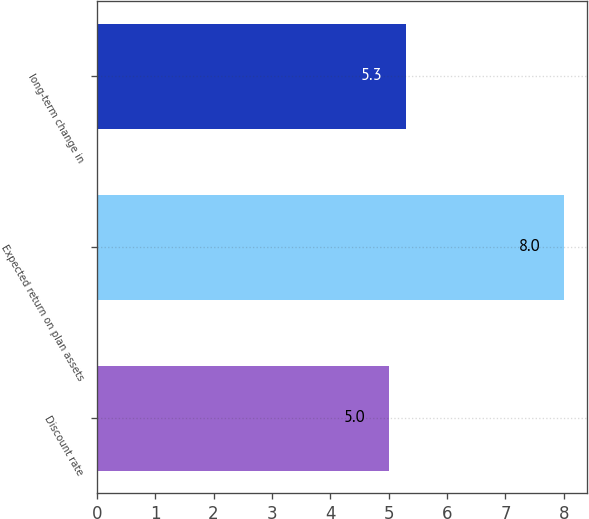Convert chart to OTSL. <chart><loc_0><loc_0><loc_500><loc_500><bar_chart><fcel>Discount rate<fcel>Expected return on plan assets<fcel>long-term change in<nl><fcel>5<fcel>8<fcel>5.3<nl></chart> 